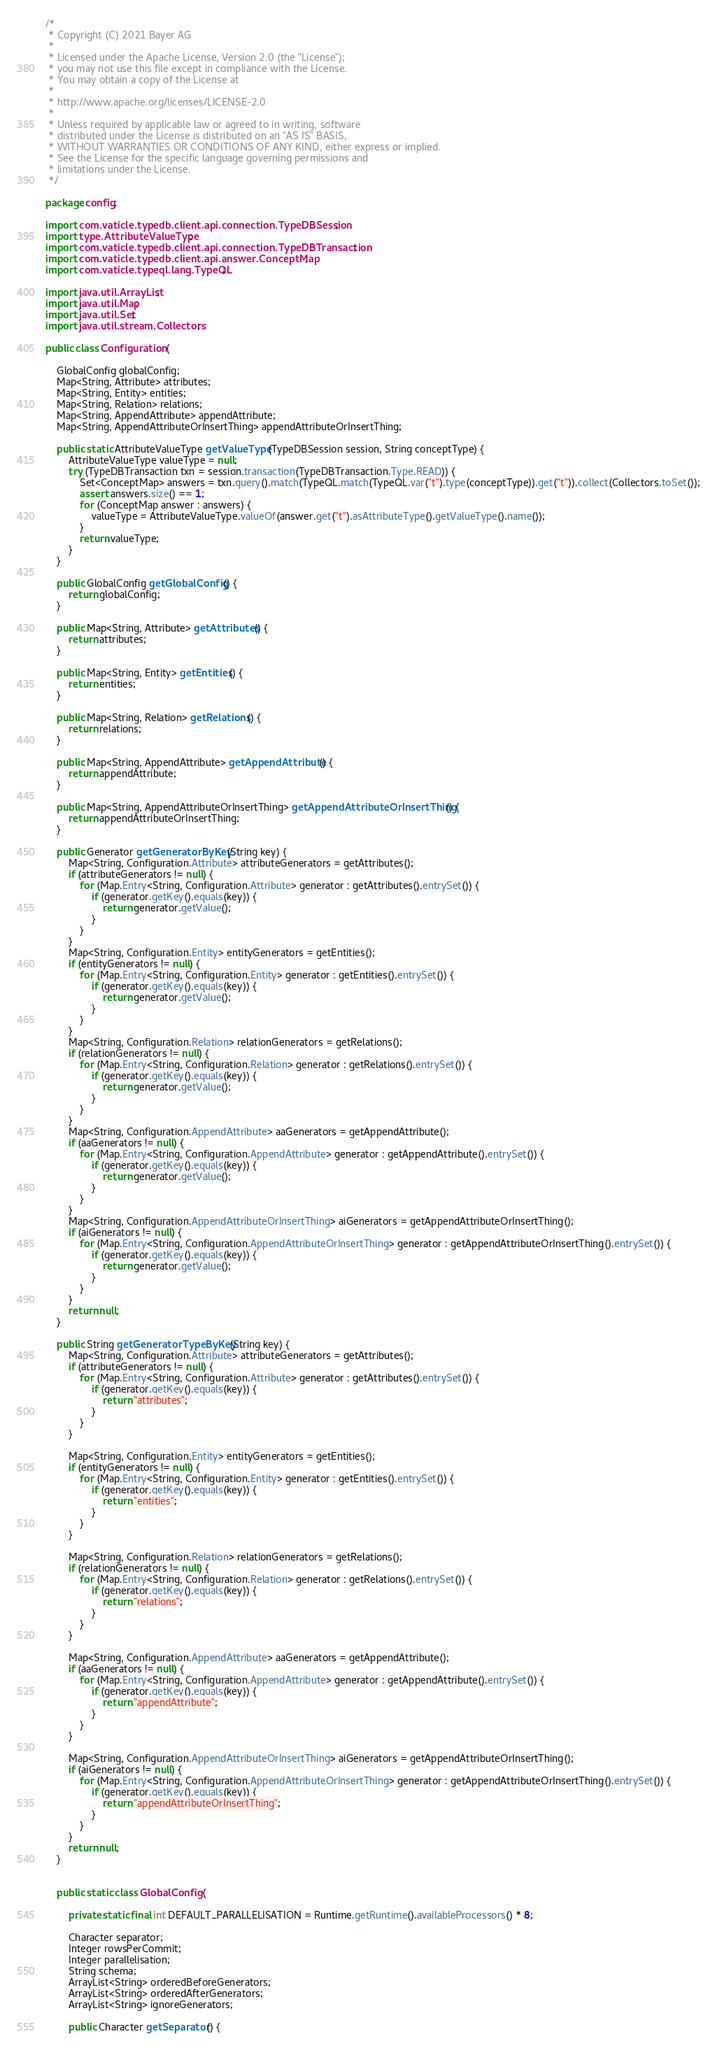<code> <loc_0><loc_0><loc_500><loc_500><_Java_>/*
 * Copyright (C) 2021 Bayer AG
 *
 * Licensed under the Apache License, Version 2.0 (the "License");
 * you may not use this file except in compliance with the License.
 * You may obtain a copy of the License at
 *
 * http://www.apache.org/licenses/LICENSE-2.0
 *
 * Unless required by applicable law or agreed to in writing, software
 * distributed under the License is distributed on an "AS IS" BASIS,
 * WITHOUT WARRANTIES OR CONDITIONS OF ANY KIND, either express or implied.
 * See the License for the specific language governing permissions and
 * limitations under the License.
 */

package config;

import com.vaticle.typedb.client.api.connection.TypeDBSession;
import type.AttributeValueType;
import com.vaticle.typedb.client.api.connection.TypeDBTransaction;
import com.vaticle.typedb.client.api.answer.ConceptMap;
import com.vaticle.typeql.lang.TypeQL;

import java.util.ArrayList;
import java.util.Map;
import java.util.Set;
import java.util.stream.Collectors;

public class Configuration {

    GlobalConfig globalConfig;
    Map<String, Attribute> attributes;
    Map<String, Entity> entities;
    Map<String, Relation> relations;
    Map<String, AppendAttribute> appendAttribute;
    Map<String, AppendAttributeOrInsertThing> appendAttributeOrInsertThing;

    public static AttributeValueType getValueType(TypeDBSession session, String conceptType) {
        AttributeValueType valueType = null;
        try (TypeDBTransaction txn = session.transaction(TypeDBTransaction.Type.READ)) {
            Set<ConceptMap> answers = txn.query().match(TypeQL.match(TypeQL.var("t").type(conceptType)).get("t")).collect(Collectors.toSet());
            assert answers.size() == 1;
            for (ConceptMap answer : answers) {
                valueType = AttributeValueType.valueOf(answer.get("t").asAttributeType().getValueType().name());
            }
            return valueType;
        }
    }

    public GlobalConfig getGlobalConfig() {
        return globalConfig;
    }

    public Map<String, Attribute> getAttributes() {
        return attributes;
    }

    public Map<String, Entity> getEntities() {
        return entities;
    }

    public Map<String, Relation> getRelations() {
        return relations;
    }

    public Map<String, AppendAttribute> getAppendAttribute() {
        return appendAttribute;
    }

    public Map<String, AppendAttributeOrInsertThing> getAppendAttributeOrInsertThing() {
        return appendAttributeOrInsertThing;
    }

    public Generator getGeneratorByKey(String key) {
        Map<String, Configuration.Attribute> attributeGenerators = getAttributes();
        if (attributeGenerators != null) {
            for (Map.Entry<String, Configuration.Attribute> generator : getAttributes().entrySet()) {
                if (generator.getKey().equals(key)) {
                    return generator.getValue();
                }
            }
        }
        Map<String, Configuration.Entity> entityGenerators = getEntities();
        if (entityGenerators != null) {
            for (Map.Entry<String, Configuration.Entity> generator : getEntities().entrySet()) {
                if (generator.getKey().equals(key)) {
                    return generator.getValue();
                }
            }
        }
        Map<String, Configuration.Relation> relationGenerators = getRelations();
        if (relationGenerators != null) {
            for (Map.Entry<String, Configuration.Relation> generator : getRelations().entrySet()) {
                if (generator.getKey().equals(key)) {
                    return generator.getValue();
                }
            }
        }
        Map<String, Configuration.AppendAttribute> aaGenerators = getAppendAttribute();
        if (aaGenerators != null) {
            for (Map.Entry<String, Configuration.AppendAttribute> generator : getAppendAttribute().entrySet()) {
                if (generator.getKey().equals(key)) {
                    return generator.getValue();
                }
            }
        }
        Map<String, Configuration.AppendAttributeOrInsertThing> aiGenerators = getAppendAttributeOrInsertThing();
        if (aiGenerators != null) {
            for (Map.Entry<String, Configuration.AppendAttributeOrInsertThing> generator : getAppendAttributeOrInsertThing().entrySet()) {
                if (generator.getKey().equals(key)) {
                    return generator.getValue();
                }
            }
        }
        return null;
    }

    public String getGeneratorTypeByKey(String key) {
        Map<String, Configuration.Attribute> attributeGenerators = getAttributes();
        if (attributeGenerators != null) {
            for (Map.Entry<String, Configuration.Attribute> generator : getAttributes().entrySet()) {
                if (generator.getKey().equals(key)) {
                    return "attributes";
                }
            }
        }

        Map<String, Configuration.Entity> entityGenerators = getEntities();
        if (entityGenerators != null) {
            for (Map.Entry<String, Configuration.Entity> generator : getEntities().entrySet()) {
                if (generator.getKey().equals(key)) {
                    return "entities";
                }
            }
        }

        Map<String, Configuration.Relation> relationGenerators = getRelations();
        if (relationGenerators != null) {
            for (Map.Entry<String, Configuration.Relation> generator : getRelations().entrySet()) {
                if (generator.getKey().equals(key)) {
                    return "relations";
                }
            }
        }

        Map<String, Configuration.AppendAttribute> aaGenerators = getAppendAttribute();
        if (aaGenerators != null) {
            for (Map.Entry<String, Configuration.AppendAttribute> generator : getAppendAttribute().entrySet()) {
                if (generator.getKey().equals(key)) {
                    return "appendAttribute";
                }
            }
        }

        Map<String, Configuration.AppendAttributeOrInsertThing> aiGenerators = getAppendAttributeOrInsertThing();
        if (aiGenerators != null) {
            for (Map.Entry<String, Configuration.AppendAttributeOrInsertThing> generator : getAppendAttributeOrInsertThing().entrySet()) {
                if (generator.getKey().equals(key)) {
                    return "appendAttributeOrInsertThing";
                }
            }
        }
        return null;
    }


    public static class GlobalConfig {

        private static final int DEFAULT_PARALLELISATION = Runtime.getRuntime().availableProcessors() * 8;

        Character separator;
        Integer rowsPerCommit;
        Integer parallelisation;
        String schema;
        ArrayList<String> orderedBeforeGenerators;
        ArrayList<String> orderedAfterGenerators;
        ArrayList<String> ignoreGenerators;

        public Character getSeparator() {</code> 